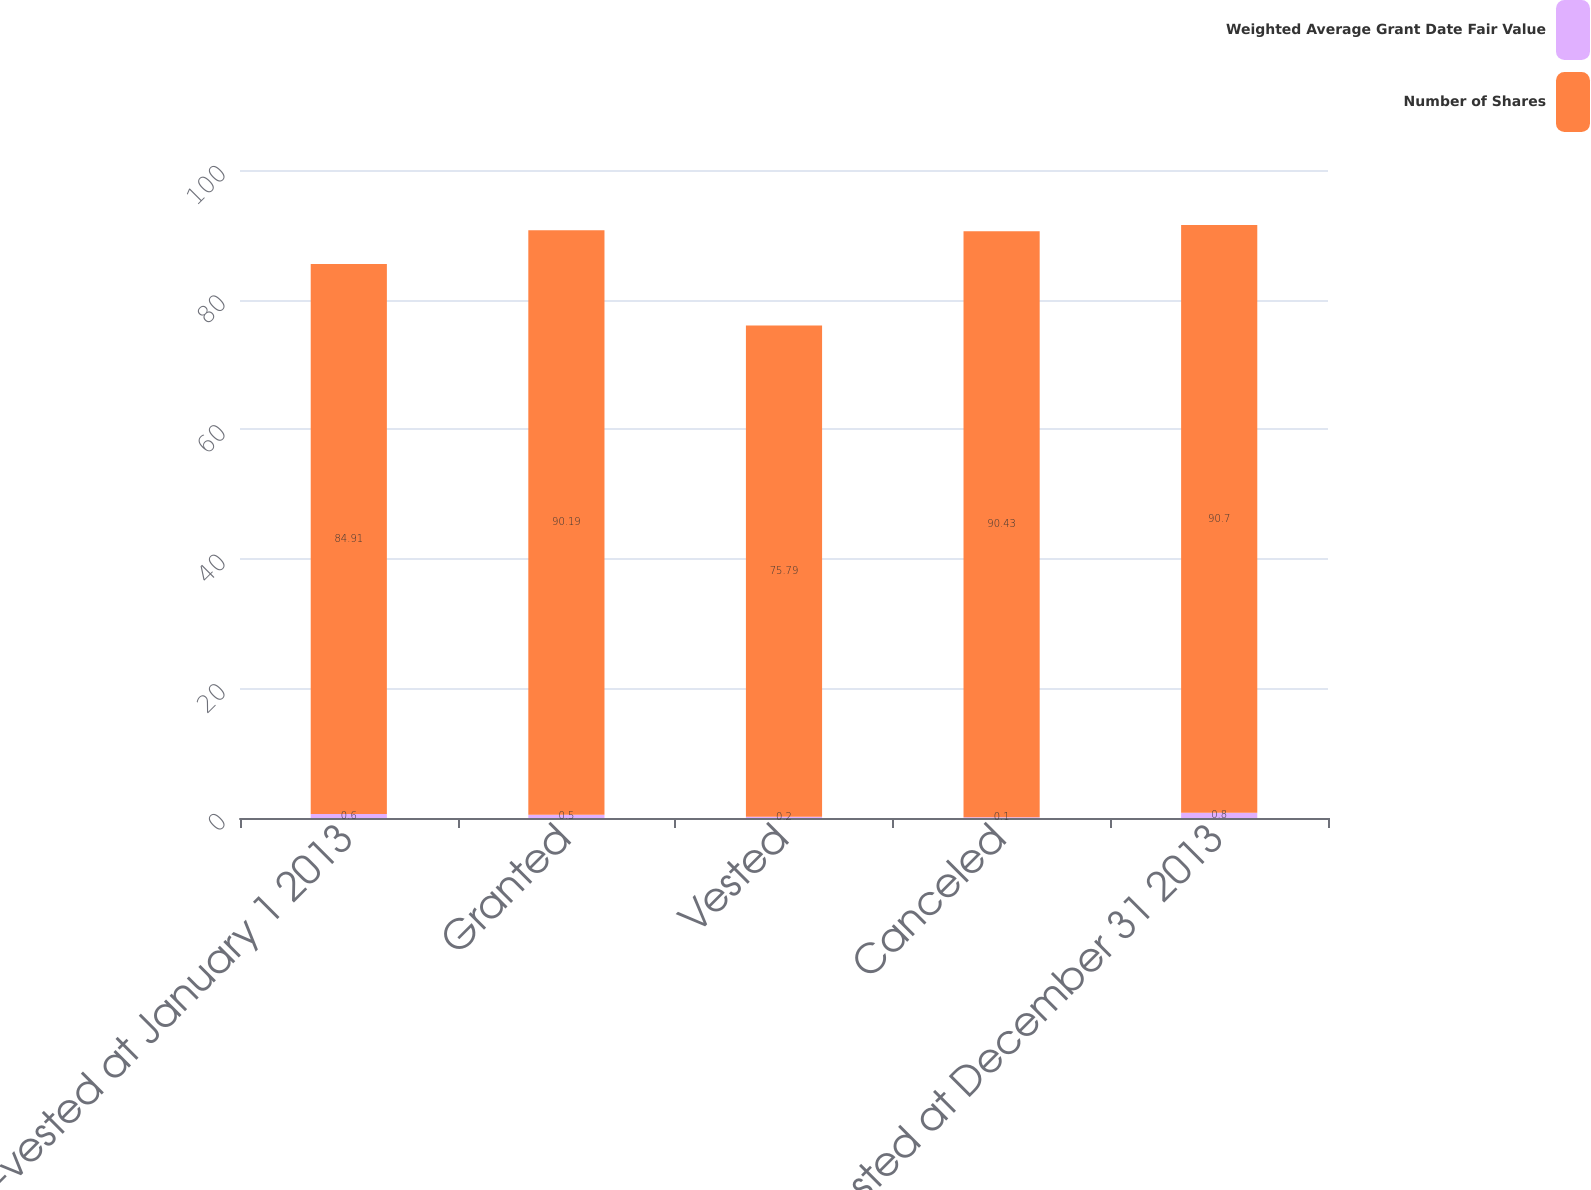Convert chart. <chart><loc_0><loc_0><loc_500><loc_500><stacked_bar_chart><ecel><fcel>Non-vested at January 1 2013<fcel>Granted<fcel>Vested<fcel>Canceled<fcel>Non-vested at December 31 2013<nl><fcel>Weighted Average Grant Date Fair Value<fcel>0.6<fcel>0.5<fcel>0.2<fcel>0.1<fcel>0.8<nl><fcel>Number of Shares<fcel>84.91<fcel>90.19<fcel>75.79<fcel>90.43<fcel>90.7<nl></chart> 